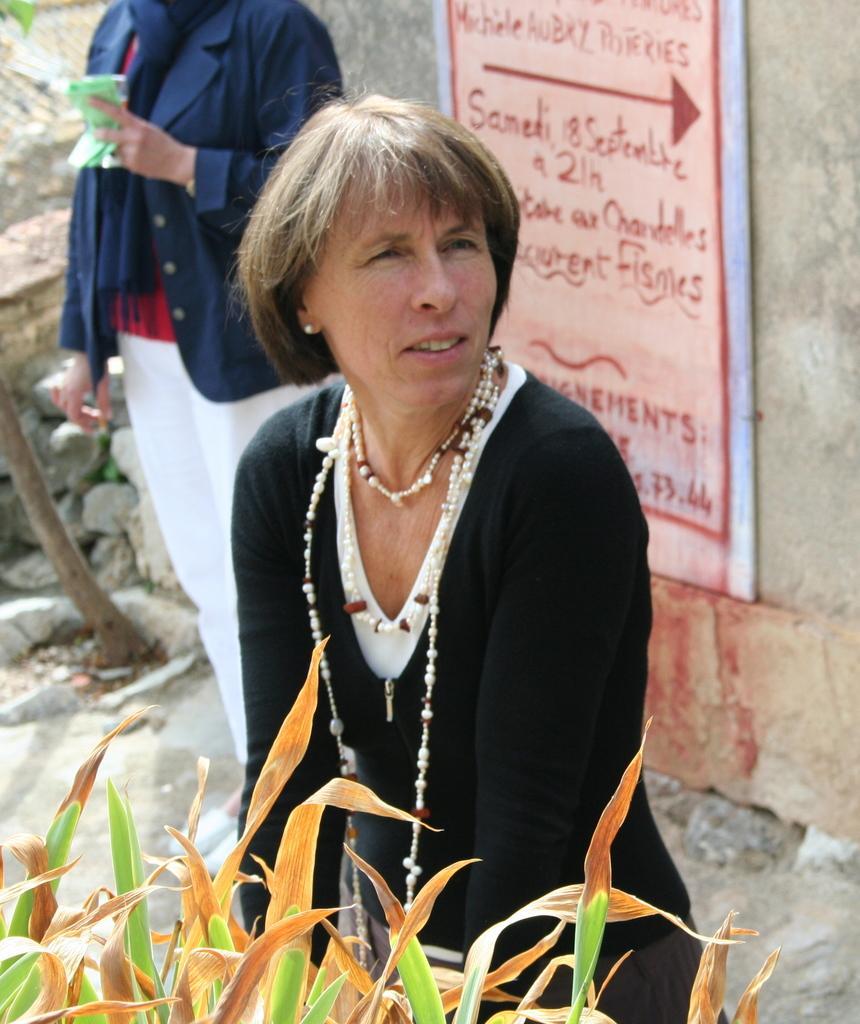Can you describe this image briefly? In this image in the front of there are leaves. In the center there is a woman standing and smiling. In the background there is a person standing and there is a board with some text written on it which is on the wall. 